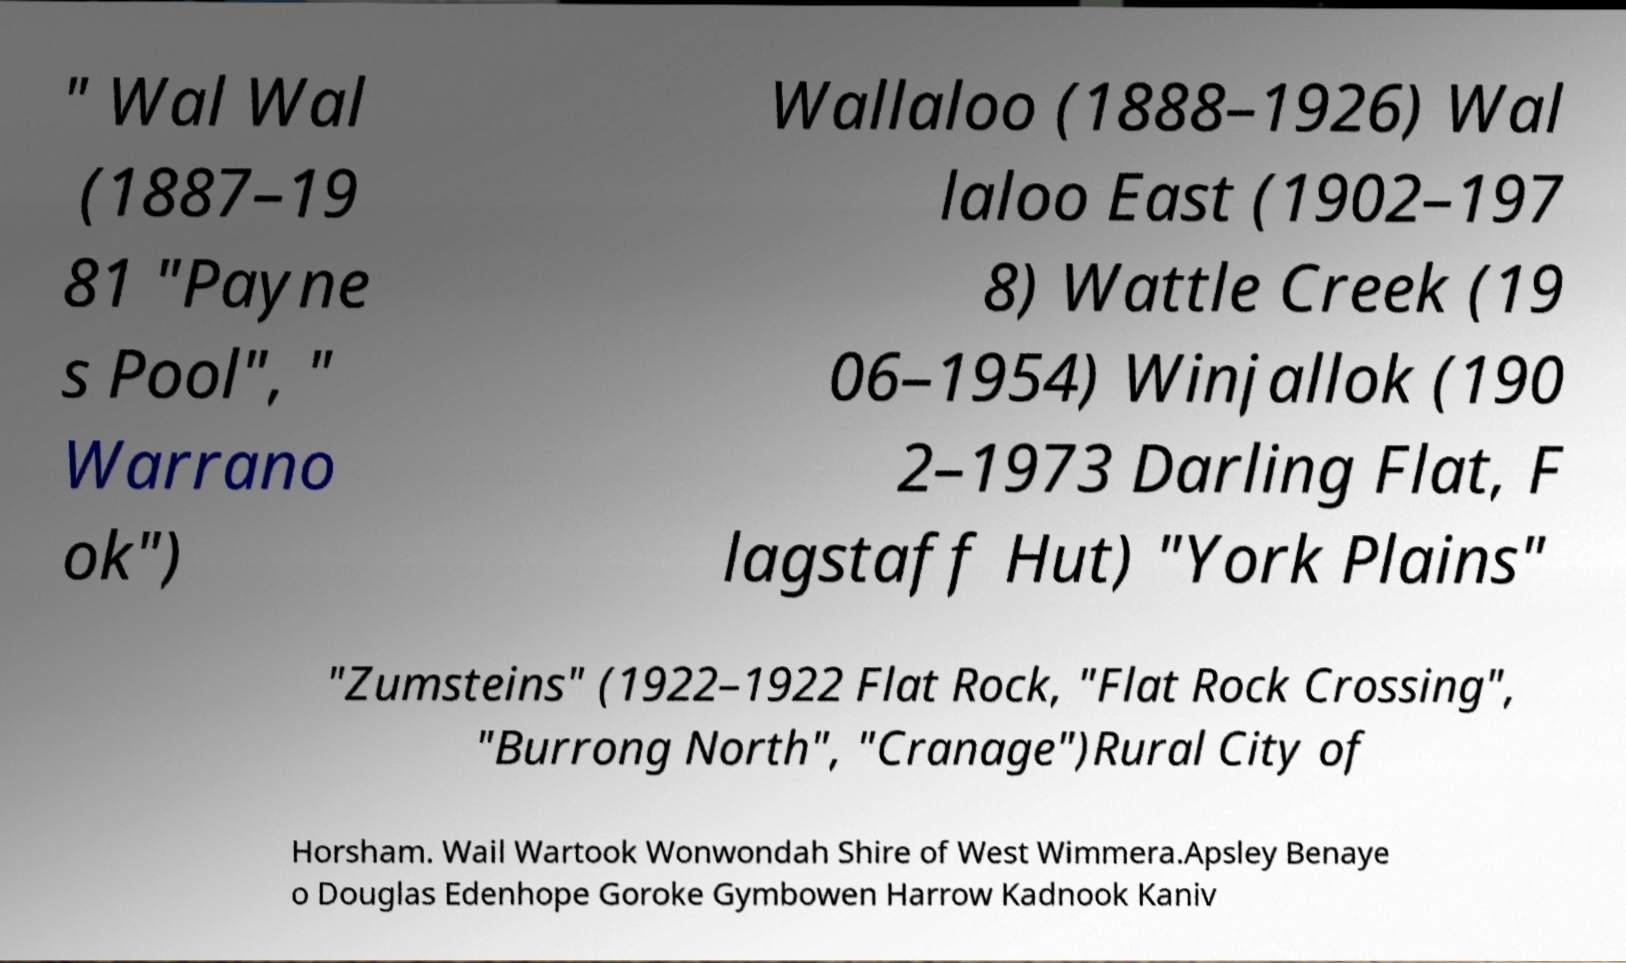Could you assist in decoding the text presented in this image and type it out clearly? " Wal Wal (1887–19 81 "Payne s Pool", " Warrano ok") Wallaloo (1888–1926) Wal laloo East (1902–197 8) Wattle Creek (19 06–1954) Winjallok (190 2–1973 Darling Flat, F lagstaff Hut) "York Plains" "Zumsteins" (1922–1922 Flat Rock, "Flat Rock Crossing", "Burrong North", "Cranage")Rural City of Horsham. Wail Wartook Wonwondah Shire of West Wimmera.Apsley Benaye o Douglas Edenhope Goroke Gymbowen Harrow Kadnook Kaniv 